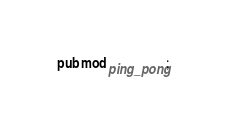<code> <loc_0><loc_0><loc_500><loc_500><_Rust_>pub mod ping_pong;
</code> 